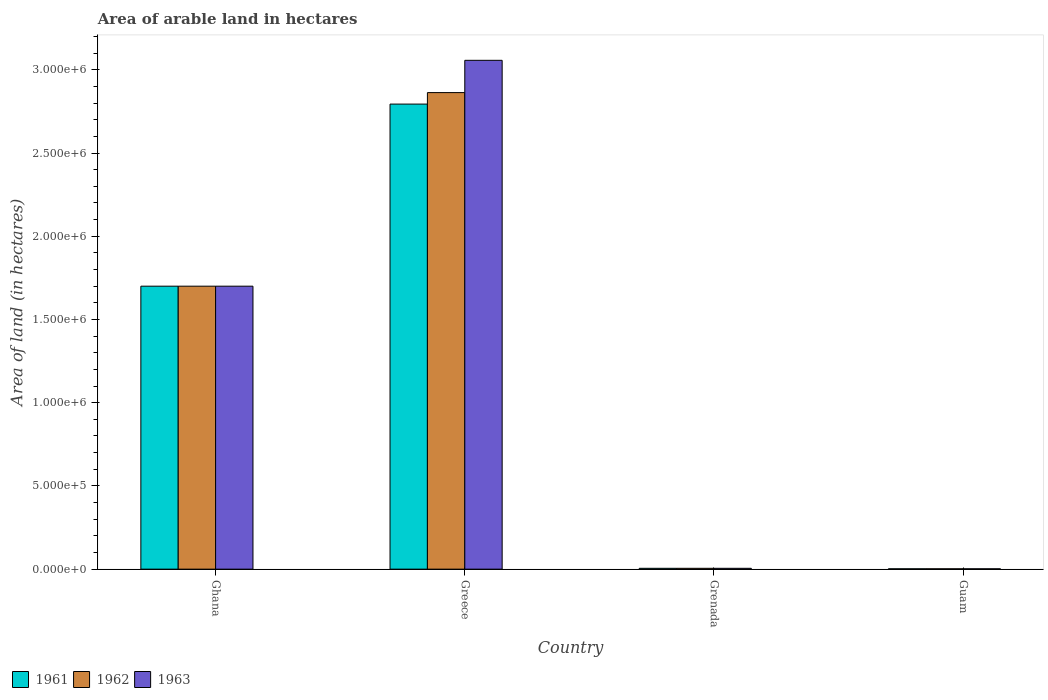How many different coloured bars are there?
Ensure brevity in your answer.  3. Are the number of bars on each tick of the X-axis equal?
Give a very brief answer. Yes. How many bars are there on the 2nd tick from the left?
Provide a succinct answer. 3. In how many cases, is the number of bars for a given country not equal to the number of legend labels?
Your answer should be very brief. 0. What is the total arable land in 1963 in Greece?
Offer a very short reply. 3.06e+06. Across all countries, what is the maximum total arable land in 1963?
Provide a succinct answer. 3.06e+06. Across all countries, what is the minimum total arable land in 1963?
Offer a very short reply. 2000. In which country was the total arable land in 1963 minimum?
Ensure brevity in your answer.  Guam. What is the total total arable land in 1962 in the graph?
Your answer should be very brief. 4.57e+06. What is the difference between the total arable land in 1961 in Ghana and that in Greece?
Give a very brief answer. -1.09e+06. What is the difference between the total arable land in 1962 in Greece and the total arable land in 1963 in Ghana?
Provide a succinct answer. 1.16e+06. What is the average total arable land in 1961 per country?
Make the answer very short. 1.13e+06. What is the difference between the total arable land of/in 1962 and total arable land of/in 1961 in Ghana?
Offer a terse response. 0. In how many countries, is the total arable land in 1962 greater than 1700000 hectares?
Ensure brevity in your answer.  1. Is the total arable land in 1961 in Ghana less than that in Guam?
Offer a terse response. No. Is the difference between the total arable land in 1962 in Ghana and Greece greater than the difference between the total arable land in 1961 in Ghana and Greece?
Your response must be concise. No. What is the difference between the highest and the second highest total arable land in 1962?
Give a very brief answer. 2.86e+06. What is the difference between the highest and the lowest total arable land in 1962?
Provide a succinct answer. 2.86e+06. Is the sum of the total arable land in 1963 in Ghana and Guam greater than the maximum total arable land in 1962 across all countries?
Provide a succinct answer. No. What does the 3rd bar from the left in Ghana represents?
Offer a very short reply. 1963. What does the 1st bar from the right in Guam represents?
Make the answer very short. 1963. Are all the bars in the graph horizontal?
Provide a short and direct response. No. What is the difference between two consecutive major ticks on the Y-axis?
Your answer should be compact. 5.00e+05. Are the values on the major ticks of Y-axis written in scientific E-notation?
Give a very brief answer. Yes. How many legend labels are there?
Your answer should be compact. 3. What is the title of the graph?
Make the answer very short. Area of arable land in hectares. Does "1982" appear as one of the legend labels in the graph?
Give a very brief answer. No. What is the label or title of the Y-axis?
Give a very brief answer. Area of land (in hectares). What is the Area of land (in hectares) in 1961 in Ghana?
Your answer should be very brief. 1.70e+06. What is the Area of land (in hectares) of 1962 in Ghana?
Provide a short and direct response. 1.70e+06. What is the Area of land (in hectares) of 1963 in Ghana?
Your response must be concise. 1.70e+06. What is the Area of land (in hectares) of 1961 in Greece?
Provide a short and direct response. 2.79e+06. What is the Area of land (in hectares) of 1962 in Greece?
Offer a very short reply. 2.86e+06. What is the Area of land (in hectares) of 1963 in Greece?
Your answer should be very brief. 3.06e+06. What is the Area of land (in hectares) in 1961 in Grenada?
Your answer should be compact. 5000. What is the Area of land (in hectares) of 1963 in Grenada?
Your answer should be compact. 5000. What is the Area of land (in hectares) of 1962 in Guam?
Give a very brief answer. 2000. What is the Area of land (in hectares) in 1963 in Guam?
Provide a succinct answer. 2000. Across all countries, what is the maximum Area of land (in hectares) of 1961?
Make the answer very short. 2.79e+06. Across all countries, what is the maximum Area of land (in hectares) in 1962?
Make the answer very short. 2.86e+06. Across all countries, what is the maximum Area of land (in hectares) in 1963?
Provide a succinct answer. 3.06e+06. Across all countries, what is the minimum Area of land (in hectares) in 1961?
Make the answer very short. 2000. Across all countries, what is the minimum Area of land (in hectares) in 1963?
Your response must be concise. 2000. What is the total Area of land (in hectares) of 1961 in the graph?
Ensure brevity in your answer.  4.50e+06. What is the total Area of land (in hectares) in 1962 in the graph?
Your response must be concise. 4.57e+06. What is the total Area of land (in hectares) of 1963 in the graph?
Give a very brief answer. 4.76e+06. What is the difference between the Area of land (in hectares) of 1961 in Ghana and that in Greece?
Provide a succinct answer. -1.09e+06. What is the difference between the Area of land (in hectares) in 1962 in Ghana and that in Greece?
Offer a terse response. -1.16e+06. What is the difference between the Area of land (in hectares) in 1963 in Ghana and that in Greece?
Make the answer very short. -1.36e+06. What is the difference between the Area of land (in hectares) of 1961 in Ghana and that in Grenada?
Ensure brevity in your answer.  1.70e+06. What is the difference between the Area of land (in hectares) of 1962 in Ghana and that in Grenada?
Provide a short and direct response. 1.70e+06. What is the difference between the Area of land (in hectares) of 1963 in Ghana and that in Grenada?
Ensure brevity in your answer.  1.70e+06. What is the difference between the Area of land (in hectares) in 1961 in Ghana and that in Guam?
Keep it short and to the point. 1.70e+06. What is the difference between the Area of land (in hectares) of 1962 in Ghana and that in Guam?
Provide a short and direct response. 1.70e+06. What is the difference between the Area of land (in hectares) in 1963 in Ghana and that in Guam?
Provide a short and direct response. 1.70e+06. What is the difference between the Area of land (in hectares) in 1961 in Greece and that in Grenada?
Your answer should be compact. 2.79e+06. What is the difference between the Area of land (in hectares) in 1962 in Greece and that in Grenada?
Provide a short and direct response. 2.86e+06. What is the difference between the Area of land (in hectares) of 1963 in Greece and that in Grenada?
Your response must be concise. 3.05e+06. What is the difference between the Area of land (in hectares) in 1961 in Greece and that in Guam?
Ensure brevity in your answer.  2.79e+06. What is the difference between the Area of land (in hectares) in 1962 in Greece and that in Guam?
Provide a succinct answer. 2.86e+06. What is the difference between the Area of land (in hectares) in 1963 in Greece and that in Guam?
Your response must be concise. 3.06e+06. What is the difference between the Area of land (in hectares) in 1961 in Grenada and that in Guam?
Your response must be concise. 3000. What is the difference between the Area of land (in hectares) in 1962 in Grenada and that in Guam?
Your response must be concise. 3000. What is the difference between the Area of land (in hectares) of 1963 in Grenada and that in Guam?
Keep it short and to the point. 3000. What is the difference between the Area of land (in hectares) in 1961 in Ghana and the Area of land (in hectares) in 1962 in Greece?
Ensure brevity in your answer.  -1.16e+06. What is the difference between the Area of land (in hectares) of 1961 in Ghana and the Area of land (in hectares) of 1963 in Greece?
Offer a very short reply. -1.36e+06. What is the difference between the Area of land (in hectares) of 1962 in Ghana and the Area of land (in hectares) of 1963 in Greece?
Keep it short and to the point. -1.36e+06. What is the difference between the Area of land (in hectares) of 1961 in Ghana and the Area of land (in hectares) of 1962 in Grenada?
Offer a terse response. 1.70e+06. What is the difference between the Area of land (in hectares) of 1961 in Ghana and the Area of land (in hectares) of 1963 in Grenada?
Offer a very short reply. 1.70e+06. What is the difference between the Area of land (in hectares) in 1962 in Ghana and the Area of land (in hectares) in 1963 in Grenada?
Offer a terse response. 1.70e+06. What is the difference between the Area of land (in hectares) in 1961 in Ghana and the Area of land (in hectares) in 1962 in Guam?
Your response must be concise. 1.70e+06. What is the difference between the Area of land (in hectares) of 1961 in Ghana and the Area of land (in hectares) of 1963 in Guam?
Your answer should be very brief. 1.70e+06. What is the difference between the Area of land (in hectares) in 1962 in Ghana and the Area of land (in hectares) in 1963 in Guam?
Ensure brevity in your answer.  1.70e+06. What is the difference between the Area of land (in hectares) in 1961 in Greece and the Area of land (in hectares) in 1962 in Grenada?
Offer a terse response. 2.79e+06. What is the difference between the Area of land (in hectares) of 1961 in Greece and the Area of land (in hectares) of 1963 in Grenada?
Make the answer very short. 2.79e+06. What is the difference between the Area of land (in hectares) of 1962 in Greece and the Area of land (in hectares) of 1963 in Grenada?
Provide a short and direct response. 2.86e+06. What is the difference between the Area of land (in hectares) in 1961 in Greece and the Area of land (in hectares) in 1962 in Guam?
Your answer should be compact. 2.79e+06. What is the difference between the Area of land (in hectares) of 1961 in Greece and the Area of land (in hectares) of 1963 in Guam?
Provide a succinct answer. 2.79e+06. What is the difference between the Area of land (in hectares) in 1962 in Greece and the Area of land (in hectares) in 1963 in Guam?
Provide a short and direct response. 2.86e+06. What is the difference between the Area of land (in hectares) in 1961 in Grenada and the Area of land (in hectares) in 1962 in Guam?
Keep it short and to the point. 3000. What is the difference between the Area of land (in hectares) of 1961 in Grenada and the Area of land (in hectares) of 1963 in Guam?
Keep it short and to the point. 3000. What is the difference between the Area of land (in hectares) of 1962 in Grenada and the Area of land (in hectares) of 1963 in Guam?
Your answer should be very brief. 3000. What is the average Area of land (in hectares) in 1961 per country?
Your response must be concise. 1.13e+06. What is the average Area of land (in hectares) in 1962 per country?
Ensure brevity in your answer.  1.14e+06. What is the average Area of land (in hectares) in 1963 per country?
Provide a succinct answer. 1.19e+06. What is the difference between the Area of land (in hectares) of 1961 and Area of land (in hectares) of 1962 in Ghana?
Give a very brief answer. 0. What is the difference between the Area of land (in hectares) of 1962 and Area of land (in hectares) of 1963 in Ghana?
Your answer should be compact. 0. What is the difference between the Area of land (in hectares) of 1961 and Area of land (in hectares) of 1962 in Greece?
Give a very brief answer. -6.90e+04. What is the difference between the Area of land (in hectares) in 1961 and Area of land (in hectares) in 1963 in Greece?
Keep it short and to the point. -2.63e+05. What is the difference between the Area of land (in hectares) in 1962 and Area of land (in hectares) in 1963 in Greece?
Keep it short and to the point. -1.94e+05. What is the ratio of the Area of land (in hectares) in 1961 in Ghana to that in Greece?
Provide a succinct answer. 0.61. What is the ratio of the Area of land (in hectares) of 1962 in Ghana to that in Greece?
Offer a very short reply. 0.59. What is the ratio of the Area of land (in hectares) in 1963 in Ghana to that in Greece?
Ensure brevity in your answer.  0.56. What is the ratio of the Area of land (in hectares) in 1961 in Ghana to that in Grenada?
Provide a succinct answer. 340. What is the ratio of the Area of land (in hectares) of 1962 in Ghana to that in Grenada?
Your response must be concise. 340. What is the ratio of the Area of land (in hectares) in 1963 in Ghana to that in Grenada?
Give a very brief answer. 340. What is the ratio of the Area of land (in hectares) of 1961 in Ghana to that in Guam?
Your answer should be very brief. 850. What is the ratio of the Area of land (in hectares) of 1962 in Ghana to that in Guam?
Ensure brevity in your answer.  850. What is the ratio of the Area of land (in hectares) of 1963 in Ghana to that in Guam?
Keep it short and to the point. 850. What is the ratio of the Area of land (in hectares) in 1961 in Greece to that in Grenada?
Ensure brevity in your answer.  558.8. What is the ratio of the Area of land (in hectares) in 1962 in Greece to that in Grenada?
Offer a terse response. 572.6. What is the ratio of the Area of land (in hectares) in 1963 in Greece to that in Grenada?
Ensure brevity in your answer.  611.4. What is the ratio of the Area of land (in hectares) of 1961 in Greece to that in Guam?
Offer a terse response. 1397. What is the ratio of the Area of land (in hectares) in 1962 in Greece to that in Guam?
Make the answer very short. 1431.5. What is the ratio of the Area of land (in hectares) of 1963 in Greece to that in Guam?
Provide a short and direct response. 1528.5. What is the ratio of the Area of land (in hectares) of 1961 in Grenada to that in Guam?
Ensure brevity in your answer.  2.5. What is the ratio of the Area of land (in hectares) of 1962 in Grenada to that in Guam?
Provide a short and direct response. 2.5. What is the ratio of the Area of land (in hectares) of 1963 in Grenada to that in Guam?
Ensure brevity in your answer.  2.5. What is the difference between the highest and the second highest Area of land (in hectares) of 1961?
Your answer should be compact. 1.09e+06. What is the difference between the highest and the second highest Area of land (in hectares) in 1962?
Offer a very short reply. 1.16e+06. What is the difference between the highest and the second highest Area of land (in hectares) in 1963?
Offer a terse response. 1.36e+06. What is the difference between the highest and the lowest Area of land (in hectares) of 1961?
Your answer should be compact. 2.79e+06. What is the difference between the highest and the lowest Area of land (in hectares) of 1962?
Provide a succinct answer. 2.86e+06. What is the difference between the highest and the lowest Area of land (in hectares) in 1963?
Keep it short and to the point. 3.06e+06. 